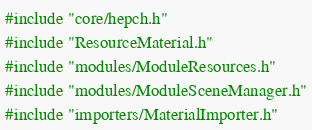Convert code to text. <code><loc_0><loc_0><loc_500><loc_500><_C++_>#include "core/hepch.h"
#include "ResourceMaterial.h"
#include "modules/ModuleResources.h"
#include "modules/ModuleSceneManager.h"
#include "importers/MaterialImporter.h"
</code> 